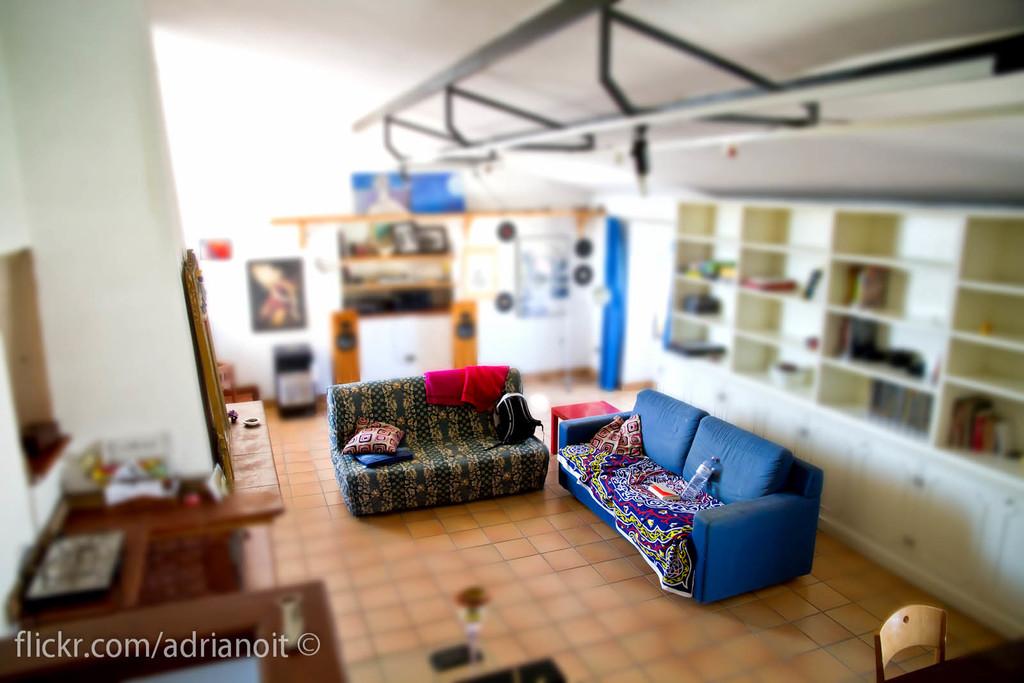What is the link to the photographer's flickr?
Give a very brief answer. Flickr.com/adrianoit. What site is written in the photo?
Provide a succinct answer. Flickr.com. 